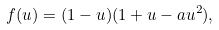<formula> <loc_0><loc_0><loc_500><loc_500>f ( u ) = ( 1 - u ) ( 1 + u - a u ^ { 2 } ) ,</formula> 